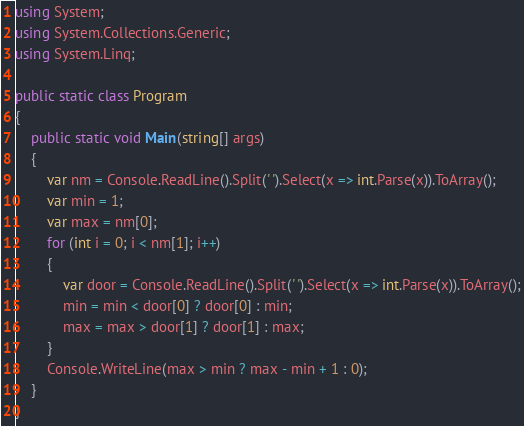Convert code to text. <code><loc_0><loc_0><loc_500><loc_500><_C#_>using System;
using System.Collections.Generic;
using System.Linq;

public static class Program
{
    public static void Main(string[] args)
    {
        var nm = Console.ReadLine().Split(' ').Select(x => int.Parse(x)).ToArray();
        var min = 1;
        var max = nm[0];
        for (int i = 0; i < nm[1]; i++)
        {
            var door = Console.ReadLine().Split(' ').Select(x => int.Parse(x)).ToArray();
            min = min < door[0] ? door[0] : min;
            max = max > door[1] ? door[1] : max;
        }
        Console.WriteLine(max > min ? max - min + 1 : 0);
    }
}</code> 